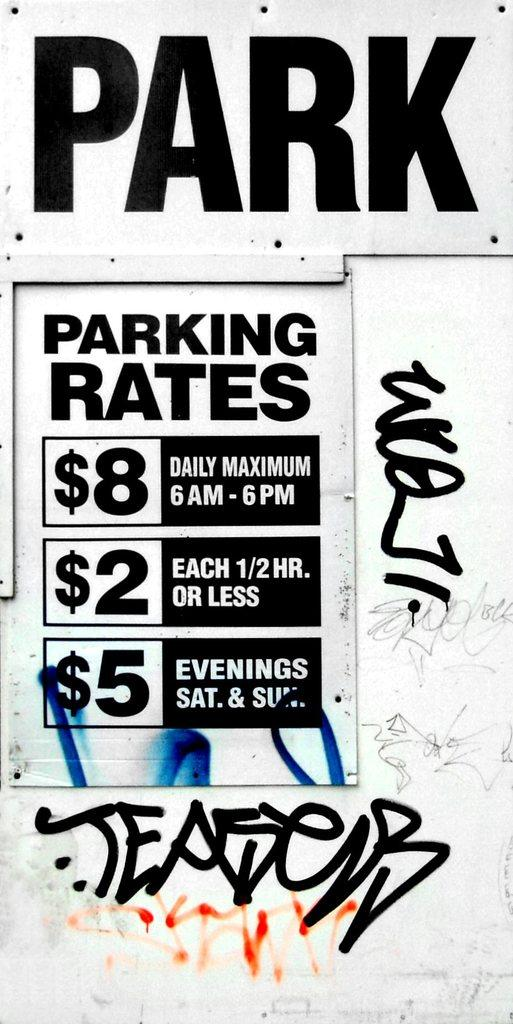Provide a one-sentence caption for the provided image. The sign explains the parking rates prices between 6am and 6 pm and at the evenings. 